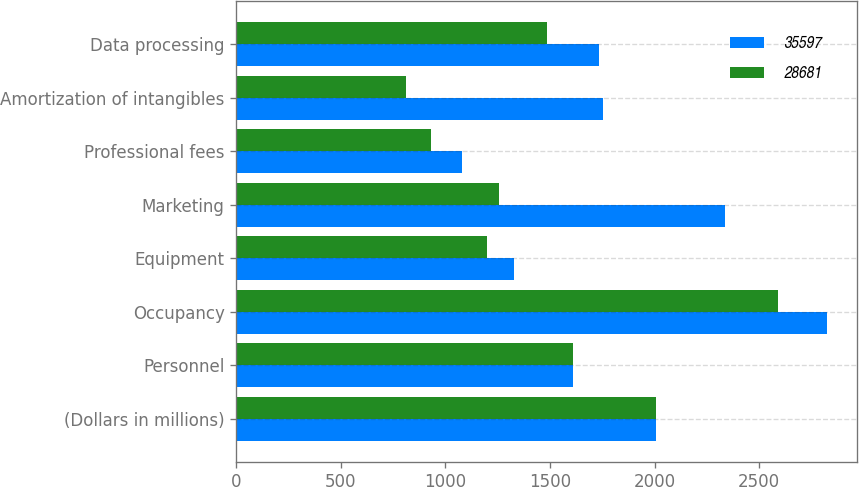<chart> <loc_0><loc_0><loc_500><loc_500><stacked_bar_chart><ecel><fcel>(Dollars in millions)<fcel>Personnel<fcel>Occupancy<fcel>Equipment<fcel>Marketing<fcel>Professional fees<fcel>Amortization of intangibles<fcel>Data processing<nl><fcel>35597<fcel>2006<fcel>1609.5<fcel>2826<fcel>1329<fcel>2336<fcel>1078<fcel>1755<fcel>1732<nl><fcel>28681<fcel>2005<fcel>1609.5<fcel>2588<fcel>1199<fcel>1255<fcel>930<fcel>809<fcel>1487<nl></chart> 